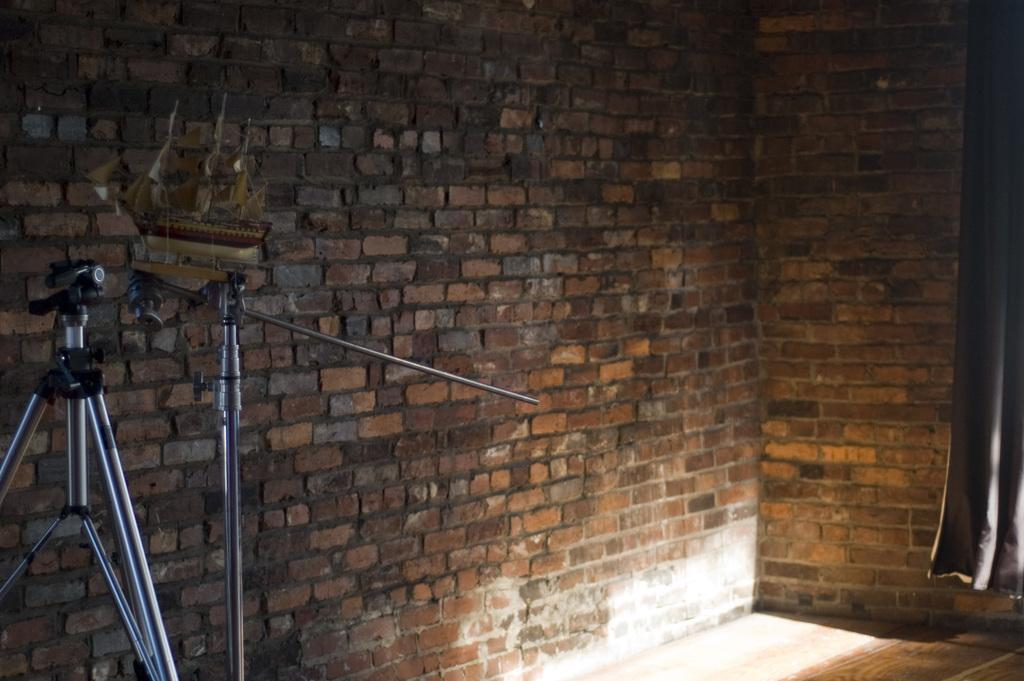What is the main object in the image? There is a camera in the image. What else can be seen in the image besides the camera? There are stands and a brick wall in the image. Is there any fabric or covering visible in the image? Yes, there is a curtain in the image. How does the camera cause an increase in the number of likes on social media? The image does not show any social media activity or interaction, so it cannot be determined how the camera might cause an increase in likes. 